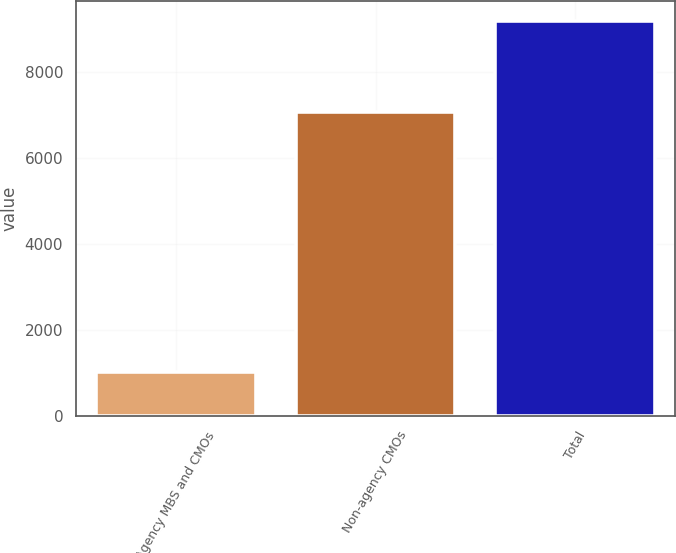Convert chart. <chart><loc_0><loc_0><loc_500><loc_500><bar_chart><fcel>Agency MBS and CMOs<fcel>Non-agency CMOs<fcel>Total<nl><fcel>1029<fcel>7084<fcel>9192<nl></chart> 